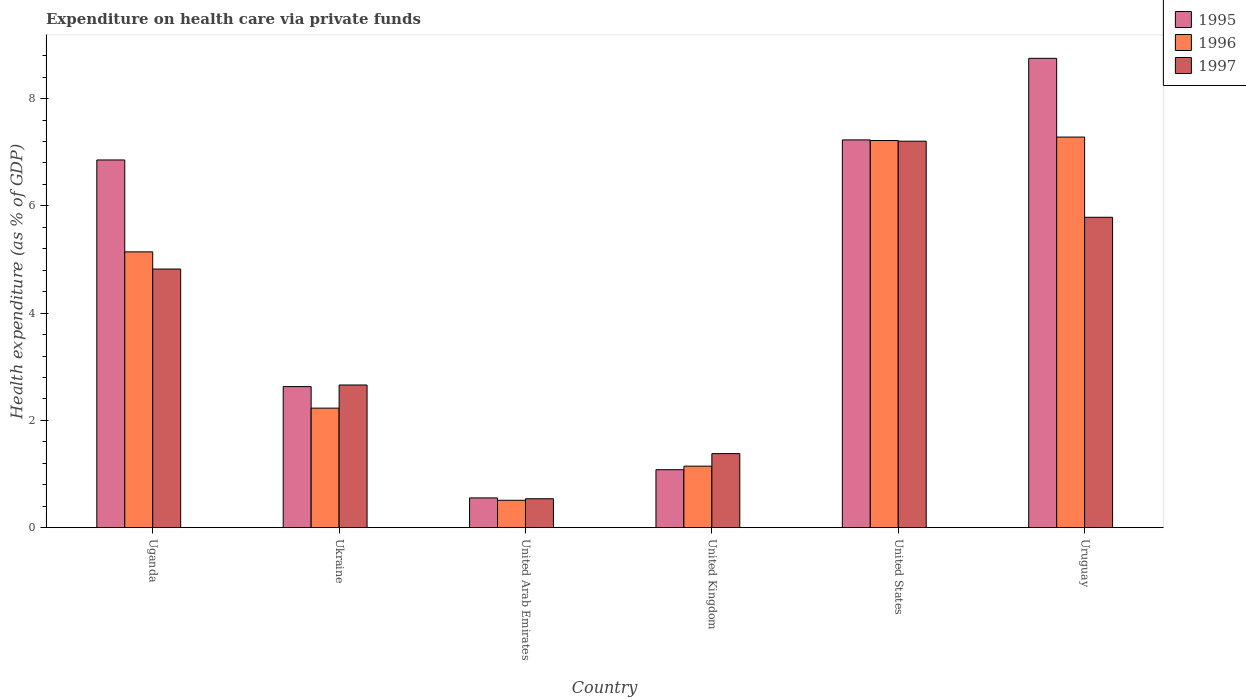Are the number of bars per tick equal to the number of legend labels?
Keep it short and to the point. Yes. Are the number of bars on each tick of the X-axis equal?
Provide a succinct answer. Yes. How many bars are there on the 5th tick from the right?
Offer a terse response. 3. What is the label of the 5th group of bars from the left?
Provide a succinct answer. United States. In how many cases, is the number of bars for a given country not equal to the number of legend labels?
Offer a terse response. 0. What is the expenditure made on health care in 1997 in Uganda?
Give a very brief answer. 4.82. Across all countries, what is the maximum expenditure made on health care in 1997?
Ensure brevity in your answer.  7.21. Across all countries, what is the minimum expenditure made on health care in 1997?
Your response must be concise. 0.54. In which country was the expenditure made on health care in 1995 maximum?
Provide a short and direct response. Uruguay. In which country was the expenditure made on health care in 1996 minimum?
Keep it short and to the point. United Arab Emirates. What is the total expenditure made on health care in 1997 in the graph?
Make the answer very short. 22.39. What is the difference between the expenditure made on health care in 1995 in Ukraine and that in United Kingdom?
Your answer should be compact. 1.55. What is the difference between the expenditure made on health care in 1997 in Ukraine and the expenditure made on health care in 1996 in United Arab Emirates?
Provide a short and direct response. 2.15. What is the average expenditure made on health care in 1996 per country?
Offer a very short reply. 3.92. What is the difference between the expenditure made on health care of/in 1996 and expenditure made on health care of/in 1995 in Ukraine?
Make the answer very short. -0.4. What is the ratio of the expenditure made on health care in 1997 in United Arab Emirates to that in United Kingdom?
Provide a short and direct response. 0.39. Is the difference between the expenditure made on health care in 1996 in United Arab Emirates and United States greater than the difference between the expenditure made on health care in 1995 in United Arab Emirates and United States?
Offer a terse response. No. What is the difference between the highest and the second highest expenditure made on health care in 1995?
Ensure brevity in your answer.  1.89. What is the difference between the highest and the lowest expenditure made on health care in 1995?
Ensure brevity in your answer.  8.2. In how many countries, is the expenditure made on health care in 1996 greater than the average expenditure made on health care in 1996 taken over all countries?
Make the answer very short. 3. Is the sum of the expenditure made on health care in 1997 in United Arab Emirates and Uruguay greater than the maximum expenditure made on health care in 1995 across all countries?
Offer a terse response. No. What does the 3rd bar from the left in United Kingdom represents?
Ensure brevity in your answer.  1997. What does the 2nd bar from the right in Ukraine represents?
Provide a short and direct response. 1996. Is it the case that in every country, the sum of the expenditure made on health care in 1997 and expenditure made on health care in 1996 is greater than the expenditure made on health care in 1995?
Offer a terse response. Yes. What is the difference between two consecutive major ticks on the Y-axis?
Offer a very short reply. 2. Does the graph contain any zero values?
Ensure brevity in your answer.  No. How many legend labels are there?
Provide a succinct answer. 3. What is the title of the graph?
Your response must be concise. Expenditure on health care via private funds. What is the label or title of the Y-axis?
Your answer should be compact. Health expenditure (as % of GDP). What is the Health expenditure (as % of GDP) of 1995 in Uganda?
Keep it short and to the point. 6.86. What is the Health expenditure (as % of GDP) of 1996 in Uganda?
Your answer should be very brief. 5.14. What is the Health expenditure (as % of GDP) of 1997 in Uganda?
Your answer should be compact. 4.82. What is the Health expenditure (as % of GDP) in 1995 in Ukraine?
Provide a short and direct response. 2.63. What is the Health expenditure (as % of GDP) in 1996 in Ukraine?
Keep it short and to the point. 2.23. What is the Health expenditure (as % of GDP) in 1997 in Ukraine?
Give a very brief answer. 2.66. What is the Health expenditure (as % of GDP) of 1995 in United Arab Emirates?
Offer a very short reply. 0.55. What is the Health expenditure (as % of GDP) in 1996 in United Arab Emirates?
Your response must be concise. 0.51. What is the Health expenditure (as % of GDP) of 1997 in United Arab Emirates?
Offer a terse response. 0.54. What is the Health expenditure (as % of GDP) in 1995 in United Kingdom?
Make the answer very short. 1.08. What is the Health expenditure (as % of GDP) in 1996 in United Kingdom?
Provide a succinct answer. 1.15. What is the Health expenditure (as % of GDP) in 1997 in United Kingdom?
Keep it short and to the point. 1.38. What is the Health expenditure (as % of GDP) of 1995 in United States?
Provide a succinct answer. 7.23. What is the Health expenditure (as % of GDP) in 1996 in United States?
Your answer should be compact. 7.22. What is the Health expenditure (as % of GDP) of 1997 in United States?
Your answer should be very brief. 7.21. What is the Health expenditure (as % of GDP) of 1995 in Uruguay?
Your response must be concise. 8.75. What is the Health expenditure (as % of GDP) of 1996 in Uruguay?
Offer a terse response. 7.28. What is the Health expenditure (as % of GDP) in 1997 in Uruguay?
Make the answer very short. 5.79. Across all countries, what is the maximum Health expenditure (as % of GDP) in 1995?
Your response must be concise. 8.75. Across all countries, what is the maximum Health expenditure (as % of GDP) of 1996?
Make the answer very short. 7.28. Across all countries, what is the maximum Health expenditure (as % of GDP) in 1997?
Make the answer very short. 7.21. Across all countries, what is the minimum Health expenditure (as % of GDP) in 1995?
Keep it short and to the point. 0.55. Across all countries, what is the minimum Health expenditure (as % of GDP) of 1996?
Keep it short and to the point. 0.51. Across all countries, what is the minimum Health expenditure (as % of GDP) of 1997?
Offer a terse response. 0.54. What is the total Health expenditure (as % of GDP) of 1995 in the graph?
Ensure brevity in your answer.  27.1. What is the total Health expenditure (as % of GDP) in 1996 in the graph?
Offer a terse response. 23.53. What is the total Health expenditure (as % of GDP) of 1997 in the graph?
Your answer should be very brief. 22.39. What is the difference between the Health expenditure (as % of GDP) in 1995 in Uganda and that in Ukraine?
Ensure brevity in your answer.  4.23. What is the difference between the Health expenditure (as % of GDP) in 1996 in Uganda and that in Ukraine?
Give a very brief answer. 2.91. What is the difference between the Health expenditure (as % of GDP) in 1997 in Uganda and that in Ukraine?
Keep it short and to the point. 2.16. What is the difference between the Health expenditure (as % of GDP) in 1995 in Uganda and that in United Arab Emirates?
Provide a succinct answer. 6.3. What is the difference between the Health expenditure (as % of GDP) of 1996 in Uganda and that in United Arab Emirates?
Your response must be concise. 4.63. What is the difference between the Health expenditure (as % of GDP) in 1997 in Uganda and that in United Arab Emirates?
Provide a short and direct response. 4.28. What is the difference between the Health expenditure (as % of GDP) of 1995 in Uganda and that in United Kingdom?
Offer a terse response. 5.78. What is the difference between the Health expenditure (as % of GDP) in 1996 in Uganda and that in United Kingdom?
Your response must be concise. 4. What is the difference between the Health expenditure (as % of GDP) of 1997 in Uganda and that in United Kingdom?
Provide a short and direct response. 3.44. What is the difference between the Health expenditure (as % of GDP) of 1995 in Uganda and that in United States?
Your answer should be compact. -0.37. What is the difference between the Health expenditure (as % of GDP) in 1996 in Uganda and that in United States?
Your answer should be very brief. -2.08. What is the difference between the Health expenditure (as % of GDP) of 1997 in Uganda and that in United States?
Your response must be concise. -2.38. What is the difference between the Health expenditure (as % of GDP) in 1995 in Uganda and that in Uruguay?
Offer a very short reply. -1.89. What is the difference between the Health expenditure (as % of GDP) in 1996 in Uganda and that in Uruguay?
Give a very brief answer. -2.14. What is the difference between the Health expenditure (as % of GDP) in 1997 in Uganda and that in Uruguay?
Give a very brief answer. -0.96. What is the difference between the Health expenditure (as % of GDP) in 1995 in Ukraine and that in United Arab Emirates?
Make the answer very short. 2.08. What is the difference between the Health expenditure (as % of GDP) of 1996 in Ukraine and that in United Arab Emirates?
Your answer should be very brief. 1.72. What is the difference between the Health expenditure (as % of GDP) of 1997 in Ukraine and that in United Arab Emirates?
Provide a short and direct response. 2.12. What is the difference between the Health expenditure (as % of GDP) in 1995 in Ukraine and that in United Kingdom?
Provide a short and direct response. 1.55. What is the difference between the Health expenditure (as % of GDP) of 1996 in Ukraine and that in United Kingdom?
Offer a very short reply. 1.08. What is the difference between the Health expenditure (as % of GDP) of 1997 in Ukraine and that in United Kingdom?
Your response must be concise. 1.28. What is the difference between the Health expenditure (as % of GDP) of 1996 in Ukraine and that in United States?
Keep it short and to the point. -4.99. What is the difference between the Health expenditure (as % of GDP) in 1997 in Ukraine and that in United States?
Your answer should be compact. -4.55. What is the difference between the Health expenditure (as % of GDP) in 1995 in Ukraine and that in Uruguay?
Make the answer very short. -6.12. What is the difference between the Health expenditure (as % of GDP) of 1996 in Ukraine and that in Uruguay?
Offer a very short reply. -5.05. What is the difference between the Health expenditure (as % of GDP) in 1997 in Ukraine and that in Uruguay?
Ensure brevity in your answer.  -3.13. What is the difference between the Health expenditure (as % of GDP) of 1995 in United Arab Emirates and that in United Kingdom?
Keep it short and to the point. -0.53. What is the difference between the Health expenditure (as % of GDP) of 1996 in United Arab Emirates and that in United Kingdom?
Make the answer very short. -0.64. What is the difference between the Health expenditure (as % of GDP) of 1997 in United Arab Emirates and that in United Kingdom?
Provide a short and direct response. -0.84. What is the difference between the Health expenditure (as % of GDP) of 1995 in United Arab Emirates and that in United States?
Your response must be concise. -6.68. What is the difference between the Health expenditure (as % of GDP) of 1996 in United Arab Emirates and that in United States?
Keep it short and to the point. -6.71. What is the difference between the Health expenditure (as % of GDP) of 1997 in United Arab Emirates and that in United States?
Keep it short and to the point. -6.67. What is the difference between the Health expenditure (as % of GDP) of 1995 in United Arab Emirates and that in Uruguay?
Ensure brevity in your answer.  -8.2. What is the difference between the Health expenditure (as % of GDP) of 1996 in United Arab Emirates and that in Uruguay?
Give a very brief answer. -6.77. What is the difference between the Health expenditure (as % of GDP) in 1997 in United Arab Emirates and that in Uruguay?
Keep it short and to the point. -5.25. What is the difference between the Health expenditure (as % of GDP) in 1995 in United Kingdom and that in United States?
Ensure brevity in your answer.  -6.15. What is the difference between the Health expenditure (as % of GDP) in 1996 in United Kingdom and that in United States?
Give a very brief answer. -6.07. What is the difference between the Health expenditure (as % of GDP) in 1997 in United Kingdom and that in United States?
Give a very brief answer. -5.83. What is the difference between the Health expenditure (as % of GDP) of 1995 in United Kingdom and that in Uruguay?
Make the answer very short. -7.67. What is the difference between the Health expenditure (as % of GDP) of 1996 in United Kingdom and that in Uruguay?
Provide a succinct answer. -6.14. What is the difference between the Health expenditure (as % of GDP) in 1997 in United Kingdom and that in Uruguay?
Offer a terse response. -4.41. What is the difference between the Health expenditure (as % of GDP) in 1995 in United States and that in Uruguay?
Provide a short and direct response. -1.52. What is the difference between the Health expenditure (as % of GDP) of 1996 in United States and that in Uruguay?
Provide a succinct answer. -0.06. What is the difference between the Health expenditure (as % of GDP) of 1997 in United States and that in Uruguay?
Your answer should be compact. 1.42. What is the difference between the Health expenditure (as % of GDP) in 1995 in Uganda and the Health expenditure (as % of GDP) in 1996 in Ukraine?
Offer a very short reply. 4.63. What is the difference between the Health expenditure (as % of GDP) of 1995 in Uganda and the Health expenditure (as % of GDP) of 1997 in Ukraine?
Provide a succinct answer. 4.2. What is the difference between the Health expenditure (as % of GDP) of 1996 in Uganda and the Health expenditure (as % of GDP) of 1997 in Ukraine?
Offer a terse response. 2.48. What is the difference between the Health expenditure (as % of GDP) in 1995 in Uganda and the Health expenditure (as % of GDP) in 1996 in United Arab Emirates?
Keep it short and to the point. 6.35. What is the difference between the Health expenditure (as % of GDP) in 1995 in Uganda and the Health expenditure (as % of GDP) in 1997 in United Arab Emirates?
Offer a very short reply. 6.32. What is the difference between the Health expenditure (as % of GDP) in 1996 in Uganda and the Health expenditure (as % of GDP) in 1997 in United Arab Emirates?
Your answer should be very brief. 4.6. What is the difference between the Health expenditure (as % of GDP) of 1995 in Uganda and the Health expenditure (as % of GDP) of 1996 in United Kingdom?
Keep it short and to the point. 5.71. What is the difference between the Health expenditure (as % of GDP) of 1995 in Uganda and the Health expenditure (as % of GDP) of 1997 in United Kingdom?
Offer a very short reply. 5.48. What is the difference between the Health expenditure (as % of GDP) in 1996 in Uganda and the Health expenditure (as % of GDP) in 1997 in United Kingdom?
Give a very brief answer. 3.76. What is the difference between the Health expenditure (as % of GDP) of 1995 in Uganda and the Health expenditure (as % of GDP) of 1996 in United States?
Keep it short and to the point. -0.36. What is the difference between the Health expenditure (as % of GDP) of 1995 in Uganda and the Health expenditure (as % of GDP) of 1997 in United States?
Your answer should be compact. -0.35. What is the difference between the Health expenditure (as % of GDP) in 1996 in Uganda and the Health expenditure (as % of GDP) in 1997 in United States?
Ensure brevity in your answer.  -2.06. What is the difference between the Health expenditure (as % of GDP) in 1995 in Uganda and the Health expenditure (as % of GDP) in 1996 in Uruguay?
Provide a succinct answer. -0.43. What is the difference between the Health expenditure (as % of GDP) of 1995 in Uganda and the Health expenditure (as % of GDP) of 1997 in Uruguay?
Make the answer very short. 1.07. What is the difference between the Health expenditure (as % of GDP) in 1996 in Uganda and the Health expenditure (as % of GDP) in 1997 in Uruguay?
Your response must be concise. -0.64. What is the difference between the Health expenditure (as % of GDP) in 1995 in Ukraine and the Health expenditure (as % of GDP) in 1996 in United Arab Emirates?
Make the answer very short. 2.12. What is the difference between the Health expenditure (as % of GDP) in 1995 in Ukraine and the Health expenditure (as % of GDP) in 1997 in United Arab Emirates?
Offer a terse response. 2.09. What is the difference between the Health expenditure (as % of GDP) in 1996 in Ukraine and the Health expenditure (as % of GDP) in 1997 in United Arab Emirates?
Make the answer very short. 1.69. What is the difference between the Health expenditure (as % of GDP) in 1995 in Ukraine and the Health expenditure (as % of GDP) in 1996 in United Kingdom?
Your answer should be very brief. 1.48. What is the difference between the Health expenditure (as % of GDP) in 1995 in Ukraine and the Health expenditure (as % of GDP) in 1997 in United Kingdom?
Your answer should be compact. 1.25. What is the difference between the Health expenditure (as % of GDP) of 1996 in Ukraine and the Health expenditure (as % of GDP) of 1997 in United Kingdom?
Make the answer very short. 0.85. What is the difference between the Health expenditure (as % of GDP) of 1995 in Ukraine and the Health expenditure (as % of GDP) of 1996 in United States?
Make the answer very short. -4.59. What is the difference between the Health expenditure (as % of GDP) of 1995 in Ukraine and the Health expenditure (as % of GDP) of 1997 in United States?
Offer a terse response. -4.58. What is the difference between the Health expenditure (as % of GDP) of 1996 in Ukraine and the Health expenditure (as % of GDP) of 1997 in United States?
Offer a very short reply. -4.98. What is the difference between the Health expenditure (as % of GDP) in 1995 in Ukraine and the Health expenditure (as % of GDP) in 1996 in Uruguay?
Your answer should be very brief. -4.65. What is the difference between the Health expenditure (as % of GDP) in 1995 in Ukraine and the Health expenditure (as % of GDP) in 1997 in Uruguay?
Keep it short and to the point. -3.16. What is the difference between the Health expenditure (as % of GDP) in 1996 in Ukraine and the Health expenditure (as % of GDP) in 1997 in Uruguay?
Offer a terse response. -3.56. What is the difference between the Health expenditure (as % of GDP) of 1995 in United Arab Emirates and the Health expenditure (as % of GDP) of 1996 in United Kingdom?
Give a very brief answer. -0.59. What is the difference between the Health expenditure (as % of GDP) of 1995 in United Arab Emirates and the Health expenditure (as % of GDP) of 1997 in United Kingdom?
Ensure brevity in your answer.  -0.83. What is the difference between the Health expenditure (as % of GDP) in 1996 in United Arab Emirates and the Health expenditure (as % of GDP) in 1997 in United Kingdom?
Your answer should be very brief. -0.87. What is the difference between the Health expenditure (as % of GDP) in 1995 in United Arab Emirates and the Health expenditure (as % of GDP) in 1996 in United States?
Provide a short and direct response. -6.66. What is the difference between the Health expenditure (as % of GDP) in 1995 in United Arab Emirates and the Health expenditure (as % of GDP) in 1997 in United States?
Ensure brevity in your answer.  -6.65. What is the difference between the Health expenditure (as % of GDP) in 1996 in United Arab Emirates and the Health expenditure (as % of GDP) in 1997 in United States?
Offer a terse response. -6.7. What is the difference between the Health expenditure (as % of GDP) in 1995 in United Arab Emirates and the Health expenditure (as % of GDP) in 1996 in Uruguay?
Provide a short and direct response. -6.73. What is the difference between the Health expenditure (as % of GDP) of 1995 in United Arab Emirates and the Health expenditure (as % of GDP) of 1997 in Uruguay?
Provide a succinct answer. -5.23. What is the difference between the Health expenditure (as % of GDP) in 1996 in United Arab Emirates and the Health expenditure (as % of GDP) in 1997 in Uruguay?
Give a very brief answer. -5.28. What is the difference between the Health expenditure (as % of GDP) of 1995 in United Kingdom and the Health expenditure (as % of GDP) of 1996 in United States?
Your response must be concise. -6.14. What is the difference between the Health expenditure (as % of GDP) of 1995 in United Kingdom and the Health expenditure (as % of GDP) of 1997 in United States?
Make the answer very short. -6.13. What is the difference between the Health expenditure (as % of GDP) in 1996 in United Kingdom and the Health expenditure (as % of GDP) in 1997 in United States?
Make the answer very short. -6.06. What is the difference between the Health expenditure (as % of GDP) in 1995 in United Kingdom and the Health expenditure (as % of GDP) in 1996 in Uruguay?
Offer a very short reply. -6.2. What is the difference between the Health expenditure (as % of GDP) in 1995 in United Kingdom and the Health expenditure (as % of GDP) in 1997 in Uruguay?
Offer a terse response. -4.71. What is the difference between the Health expenditure (as % of GDP) of 1996 in United Kingdom and the Health expenditure (as % of GDP) of 1997 in Uruguay?
Keep it short and to the point. -4.64. What is the difference between the Health expenditure (as % of GDP) in 1995 in United States and the Health expenditure (as % of GDP) in 1996 in Uruguay?
Your answer should be very brief. -0.05. What is the difference between the Health expenditure (as % of GDP) in 1995 in United States and the Health expenditure (as % of GDP) in 1997 in Uruguay?
Give a very brief answer. 1.44. What is the difference between the Health expenditure (as % of GDP) in 1996 in United States and the Health expenditure (as % of GDP) in 1997 in Uruguay?
Make the answer very short. 1.43. What is the average Health expenditure (as % of GDP) of 1995 per country?
Make the answer very short. 4.52. What is the average Health expenditure (as % of GDP) in 1996 per country?
Provide a short and direct response. 3.92. What is the average Health expenditure (as % of GDP) of 1997 per country?
Provide a short and direct response. 3.73. What is the difference between the Health expenditure (as % of GDP) of 1995 and Health expenditure (as % of GDP) of 1996 in Uganda?
Offer a very short reply. 1.71. What is the difference between the Health expenditure (as % of GDP) in 1995 and Health expenditure (as % of GDP) in 1997 in Uganda?
Your answer should be very brief. 2.03. What is the difference between the Health expenditure (as % of GDP) in 1996 and Health expenditure (as % of GDP) in 1997 in Uganda?
Your answer should be compact. 0.32. What is the difference between the Health expenditure (as % of GDP) of 1995 and Health expenditure (as % of GDP) of 1996 in Ukraine?
Offer a very short reply. 0.4. What is the difference between the Health expenditure (as % of GDP) in 1995 and Health expenditure (as % of GDP) in 1997 in Ukraine?
Your answer should be very brief. -0.03. What is the difference between the Health expenditure (as % of GDP) of 1996 and Health expenditure (as % of GDP) of 1997 in Ukraine?
Your answer should be compact. -0.43. What is the difference between the Health expenditure (as % of GDP) in 1995 and Health expenditure (as % of GDP) in 1996 in United Arab Emirates?
Ensure brevity in your answer.  0.04. What is the difference between the Health expenditure (as % of GDP) of 1995 and Health expenditure (as % of GDP) of 1997 in United Arab Emirates?
Provide a short and direct response. 0.02. What is the difference between the Health expenditure (as % of GDP) of 1996 and Health expenditure (as % of GDP) of 1997 in United Arab Emirates?
Offer a very short reply. -0.03. What is the difference between the Health expenditure (as % of GDP) in 1995 and Health expenditure (as % of GDP) in 1996 in United Kingdom?
Provide a short and direct response. -0.07. What is the difference between the Health expenditure (as % of GDP) of 1996 and Health expenditure (as % of GDP) of 1997 in United Kingdom?
Provide a short and direct response. -0.23. What is the difference between the Health expenditure (as % of GDP) of 1995 and Health expenditure (as % of GDP) of 1996 in United States?
Make the answer very short. 0.01. What is the difference between the Health expenditure (as % of GDP) of 1995 and Health expenditure (as % of GDP) of 1997 in United States?
Your answer should be very brief. 0.02. What is the difference between the Health expenditure (as % of GDP) in 1996 and Health expenditure (as % of GDP) in 1997 in United States?
Provide a short and direct response. 0.01. What is the difference between the Health expenditure (as % of GDP) in 1995 and Health expenditure (as % of GDP) in 1996 in Uruguay?
Offer a very short reply. 1.47. What is the difference between the Health expenditure (as % of GDP) of 1995 and Health expenditure (as % of GDP) of 1997 in Uruguay?
Give a very brief answer. 2.96. What is the difference between the Health expenditure (as % of GDP) of 1996 and Health expenditure (as % of GDP) of 1997 in Uruguay?
Provide a short and direct response. 1.5. What is the ratio of the Health expenditure (as % of GDP) in 1995 in Uganda to that in Ukraine?
Offer a very short reply. 2.61. What is the ratio of the Health expenditure (as % of GDP) in 1996 in Uganda to that in Ukraine?
Your answer should be very brief. 2.31. What is the ratio of the Health expenditure (as % of GDP) in 1997 in Uganda to that in Ukraine?
Provide a short and direct response. 1.81. What is the ratio of the Health expenditure (as % of GDP) in 1995 in Uganda to that in United Arab Emirates?
Offer a terse response. 12.37. What is the ratio of the Health expenditure (as % of GDP) in 1996 in Uganda to that in United Arab Emirates?
Offer a terse response. 10.08. What is the ratio of the Health expenditure (as % of GDP) in 1997 in Uganda to that in United Arab Emirates?
Your answer should be very brief. 8.95. What is the ratio of the Health expenditure (as % of GDP) of 1995 in Uganda to that in United Kingdom?
Offer a very short reply. 6.35. What is the ratio of the Health expenditure (as % of GDP) of 1996 in Uganda to that in United Kingdom?
Your response must be concise. 4.49. What is the ratio of the Health expenditure (as % of GDP) in 1997 in Uganda to that in United Kingdom?
Offer a very short reply. 3.49. What is the ratio of the Health expenditure (as % of GDP) of 1995 in Uganda to that in United States?
Offer a very short reply. 0.95. What is the ratio of the Health expenditure (as % of GDP) in 1996 in Uganda to that in United States?
Make the answer very short. 0.71. What is the ratio of the Health expenditure (as % of GDP) of 1997 in Uganda to that in United States?
Provide a short and direct response. 0.67. What is the ratio of the Health expenditure (as % of GDP) in 1995 in Uganda to that in Uruguay?
Your response must be concise. 0.78. What is the ratio of the Health expenditure (as % of GDP) of 1996 in Uganda to that in Uruguay?
Ensure brevity in your answer.  0.71. What is the ratio of the Health expenditure (as % of GDP) of 1997 in Uganda to that in Uruguay?
Your answer should be very brief. 0.83. What is the ratio of the Health expenditure (as % of GDP) of 1995 in Ukraine to that in United Arab Emirates?
Make the answer very short. 4.74. What is the ratio of the Health expenditure (as % of GDP) in 1996 in Ukraine to that in United Arab Emirates?
Your answer should be very brief. 4.37. What is the ratio of the Health expenditure (as % of GDP) of 1997 in Ukraine to that in United Arab Emirates?
Your response must be concise. 4.94. What is the ratio of the Health expenditure (as % of GDP) of 1995 in Ukraine to that in United Kingdom?
Your answer should be compact. 2.43. What is the ratio of the Health expenditure (as % of GDP) of 1996 in Ukraine to that in United Kingdom?
Provide a short and direct response. 1.94. What is the ratio of the Health expenditure (as % of GDP) of 1997 in Ukraine to that in United Kingdom?
Make the answer very short. 1.93. What is the ratio of the Health expenditure (as % of GDP) in 1995 in Ukraine to that in United States?
Provide a short and direct response. 0.36. What is the ratio of the Health expenditure (as % of GDP) of 1996 in Ukraine to that in United States?
Make the answer very short. 0.31. What is the ratio of the Health expenditure (as % of GDP) of 1997 in Ukraine to that in United States?
Your response must be concise. 0.37. What is the ratio of the Health expenditure (as % of GDP) of 1995 in Ukraine to that in Uruguay?
Keep it short and to the point. 0.3. What is the ratio of the Health expenditure (as % of GDP) of 1996 in Ukraine to that in Uruguay?
Offer a terse response. 0.31. What is the ratio of the Health expenditure (as % of GDP) of 1997 in Ukraine to that in Uruguay?
Offer a very short reply. 0.46. What is the ratio of the Health expenditure (as % of GDP) in 1995 in United Arab Emirates to that in United Kingdom?
Give a very brief answer. 0.51. What is the ratio of the Health expenditure (as % of GDP) in 1996 in United Arab Emirates to that in United Kingdom?
Offer a terse response. 0.45. What is the ratio of the Health expenditure (as % of GDP) of 1997 in United Arab Emirates to that in United Kingdom?
Offer a terse response. 0.39. What is the ratio of the Health expenditure (as % of GDP) of 1995 in United Arab Emirates to that in United States?
Keep it short and to the point. 0.08. What is the ratio of the Health expenditure (as % of GDP) in 1996 in United Arab Emirates to that in United States?
Your answer should be compact. 0.07. What is the ratio of the Health expenditure (as % of GDP) of 1997 in United Arab Emirates to that in United States?
Your answer should be very brief. 0.07. What is the ratio of the Health expenditure (as % of GDP) of 1995 in United Arab Emirates to that in Uruguay?
Provide a succinct answer. 0.06. What is the ratio of the Health expenditure (as % of GDP) of 1996 in United Arab Emirates to that in Uruguay?
Ensure brevity in your answer.  0.07. What is the ratio of the Health expenditure (as % of GDP) in 1997 in United Arab Emirates to that in Uruguay?
Your answer should be compact. 0.09. What is the ratio of the Health expenditure (as % of GDP) of 1995 in United Kingdom to that in United States?
Your answer should be very brief. 0.15. What is the ratio of the Health expenditure (as % of GDP) of 1996 in United Kingdom to that in United States?
Offer a very short reply. 0.16. What is the ratio of the Health expenditure (as % of GDP) in 1997 in United Kingdom to that in United States?
Give a very brief answer. 0.19. What is the ratio of the Health expenditure (as % of GDP) in 1995 in United Kingdom to that in Uruguay?
Provide a succinct answer. 0.12. What is the ratio of the Health expenditure (as % of GDP) in 1996 in United Kingdom to that in Uruguay?
Provide a succinct answer. 0.16. What is the ratio of the Health expenditure (as % of GDP) in 1997 in United Kingdom to that in Uruguay?
Keep it short and to the point. 0.24. What is the ratio of the Health expenditure (as % of GDP) of 1995 in United States to that in Uruguay?
Make the answer very short. 0.83. What is the ratio of the Health expenditure (as % of GDP) of 1997 in United States to that in Uruguay?
Ensure brevity in your answer.  1.25. What is the difference between the highest and the second highest Health expenditure (as % of GDP) of 1995?
Offer a very short reply. 1.52. What is the difference between the highest and the second highest Health expenditure (as % of GDP) in 1996?
Keep it short and to the point. 0.06. What is the difference between the highest and the second highest Health expenditure (as % of GDP) of 1997?
Ensure brevity in your answer.  1.42. What is the difference between the highest and the lowest Health expenditure (as % of GDP) in 1995?
Your response must be concise. 8.2. What is the difference between the highest and the lowest Health expenditure (as % of GDP) in 1996?
Ensure brevity in your answer.  6.77. What is the difference between the highest and the lowest Health expenditure (as % of GDP) in 1997?
Ensure brevity in your answer.  6.67. 